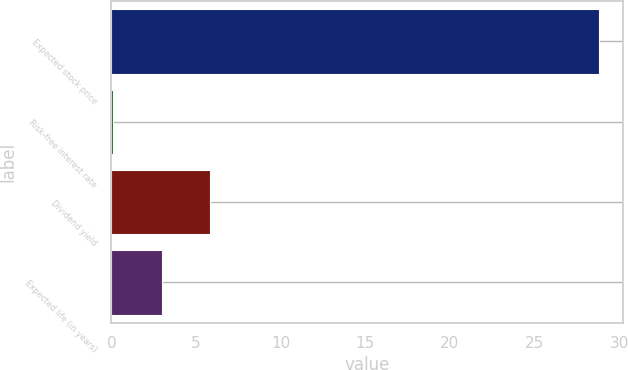Convert chart. <chart><loc_0><loc_0><loc_500><loc_500><bar_chart><fcel>Expected stock price<fcel>Risk-free interest rate<fcel>Dividend yield<fcel>Expected life (in years)<nl><fcel>28.8<fcel>0.1<fcel>5.84<fcel>2.97<nl></chart> 